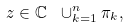Convert formula to latex. <formula><loc_0><loc_0><loc_500><loc_500>z \in { \mathbb { C } } \ \cup _ { k = 1 } ^ { n } \pi _ { k } ,</formula> 